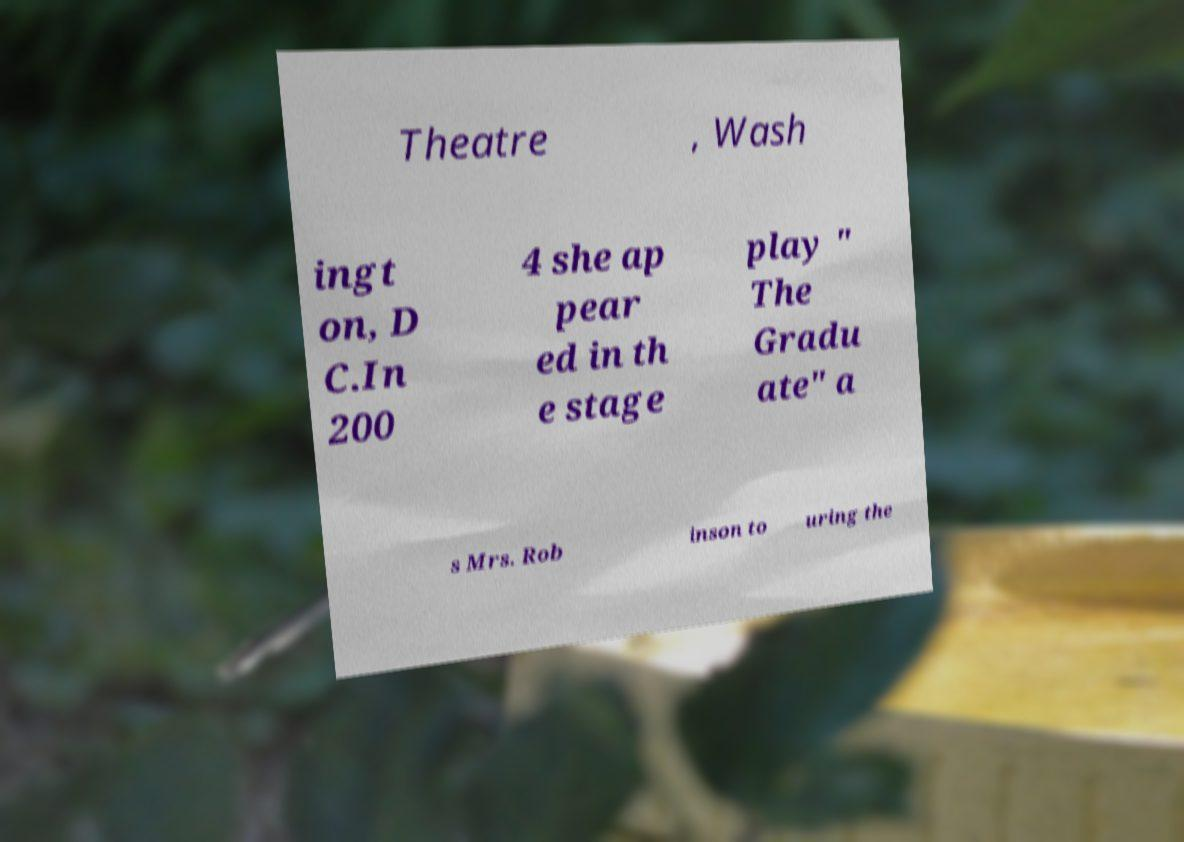For documentation purposes, I need the text within this image transcribed. Could you provide that? Theatre , Wash ingt on, D C.In 200 4 she ap pear ed in th e stage play " The Gradu ate" a s Mrs. Rob inson to uring the 